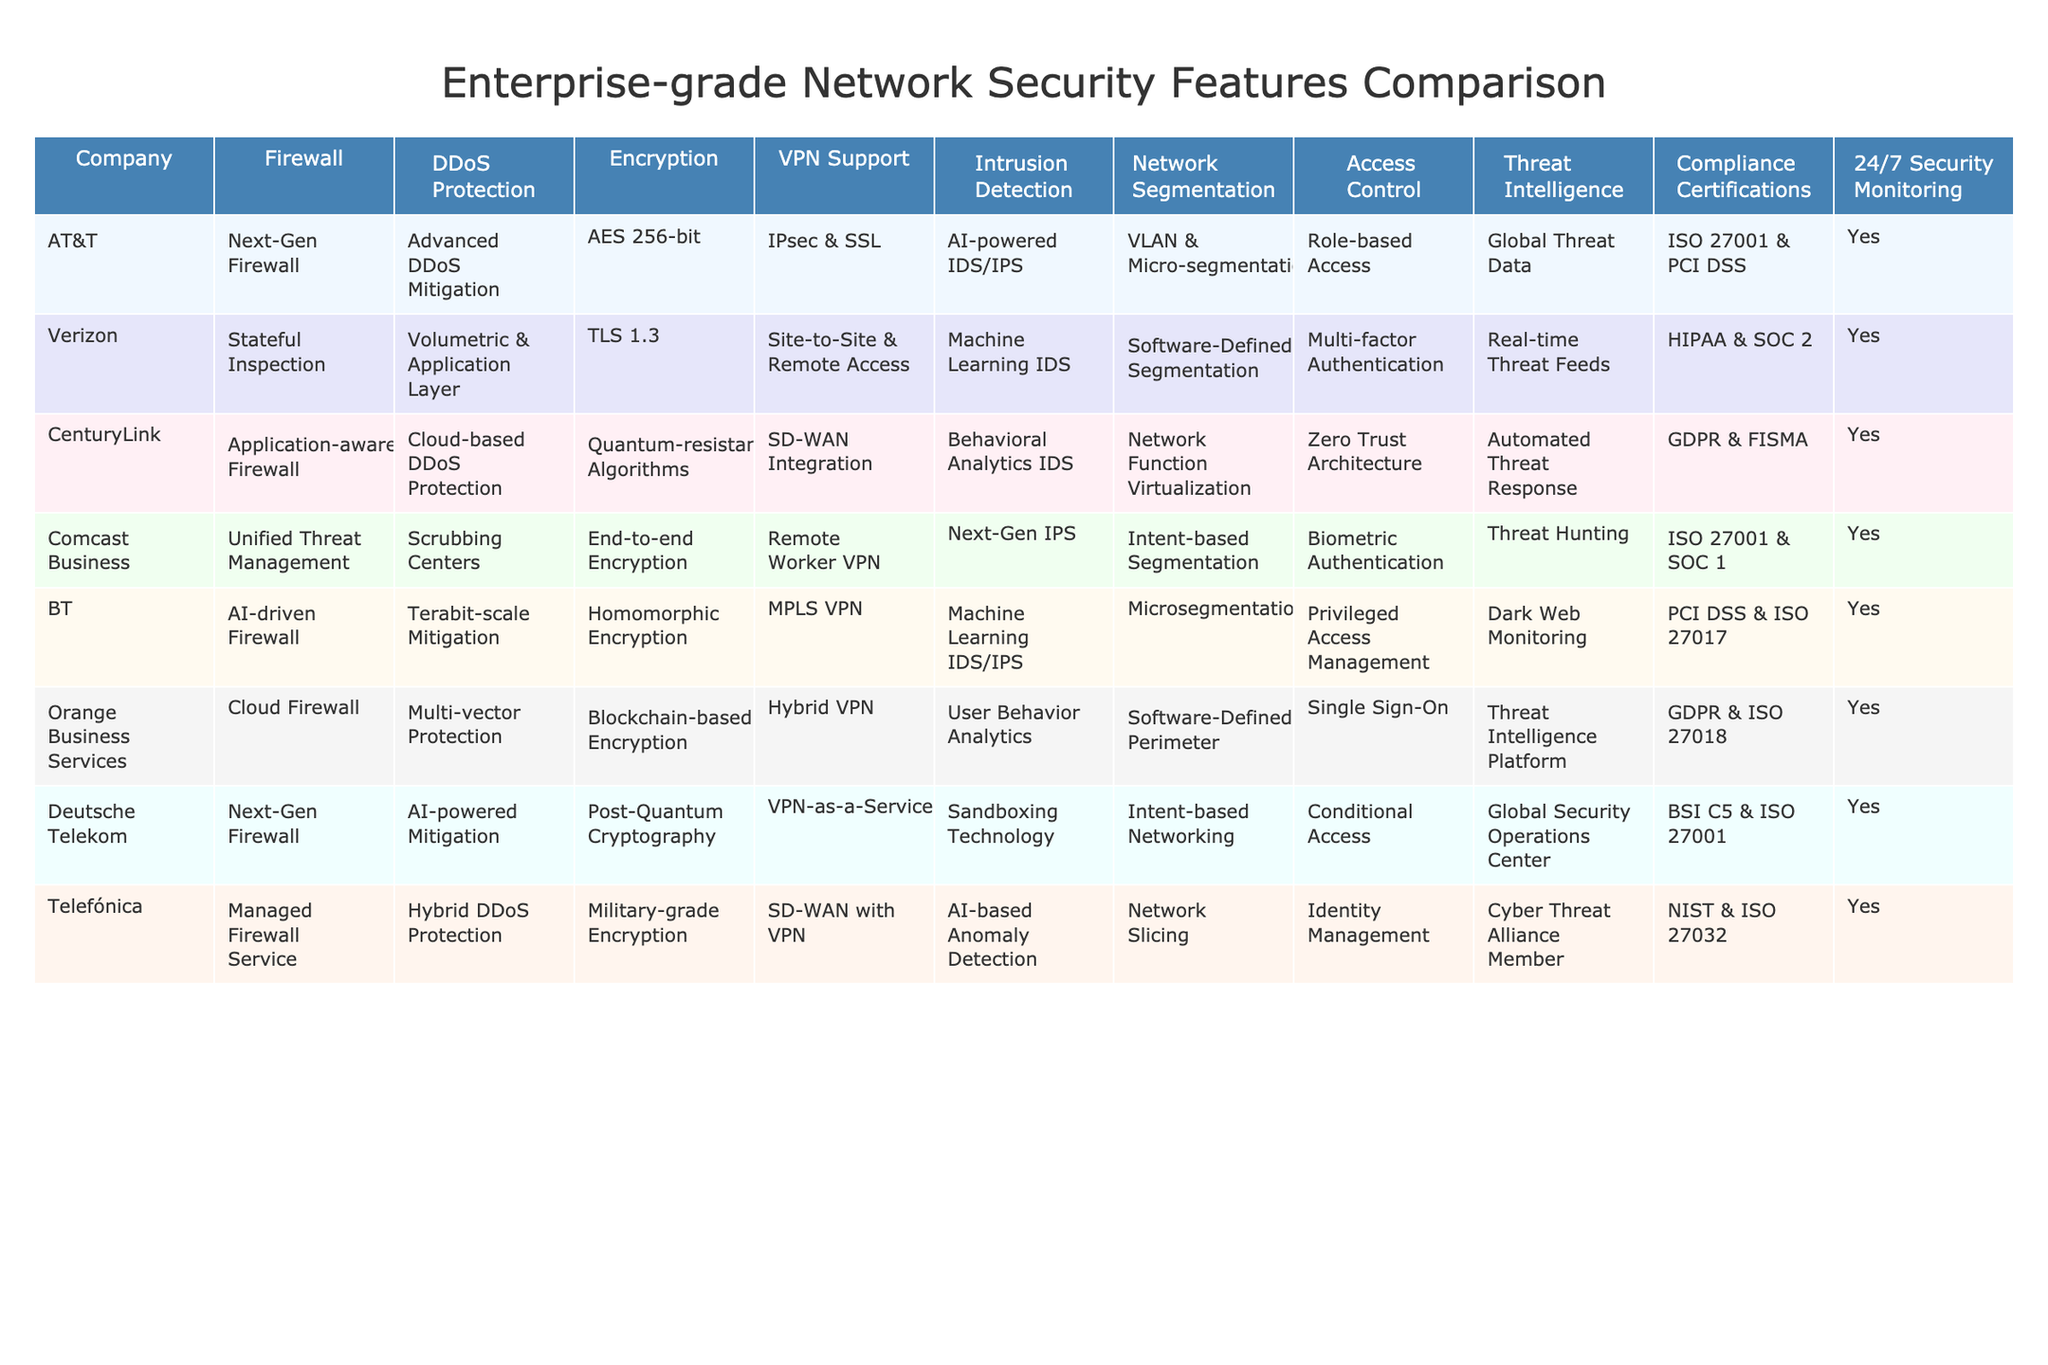What type of firewall does CenturyLink use? According to the table, CenturyLink uses an application-aware firewall. This specific detail can be found in the 'Firewall' column corresponding to the CenturyLink row.
Answer: Application-aware Firewall Which companies offer advanced DDoS protection? The companies that offer advanced DDoS protection are AT&T with advanced DDoS mitigation, Verizon with volumetric and application layer protection, and CenturyLink with cloud-based DDoS protection. This is established by looking under the 'DDoS Protection' column for each company's name.
Answer: AT&T, Verizon, CenturyLink Does Comcast Business provide 24/7 security monitoring? The table indicates that Comcast Business does provide 24/7 security monitoring, as indicated by the 'Yes' in the '24/7 Security Monitoring' column for that company.
Answer: Yes How many companies support VPN? By reviewing the table, it can be observed that all companies listed support VPN services, as each corresponding row has a VPN support option mentioned under the 'VPN Support' column. Since there are 8 companies listed, the count is 8.
Answer: 8 Which company has the highest level of encryption? The question is a bit complex as it requires assessing the encryption types listed. CenturyLink mentions quantum-resistant algorithms which are considered highly secure, while other companies mention AES 256-bit or military-grade encryption which are also high but not at the same advanced level. Thus, CenturyLink leads in encryption sophistication.
Answer: CenturyLink How does the compliance certification of BT differ from that of Verizon? BT has PCI DSS and ISO 27017, while Verizon has HIPAA and SOC 2. This means BT's certifications focus on payment security and cloud security, while Verizon's are in healthcare and organizational security compliance. The answer arises from examining the specific certifications listed in the 'Compliance Certifications' column for both companies.
Answer: Different focus areas Which company offers network segmentation through a zero-trust architecture? The table shows that CenturyLink implements network segmentation through a zero trust architecture, which can be found under the 'Network Segmentation' column in its respective row.
Answer: CenturyLink Compare the encryption methods of AT&T and Deutsche Telekom. AT&T employs AES 256-bit encryption, while Deutsche Telekom uses post-quantum cryptography, which is future-proof against quantum attacks. This comparison requires observing the 'Encryption' column for both companies and understanding the security levels of each encryption method.
Answer: Different encryption approaches How many companies use AI in their intrusion detection systems? From the table, it's evident that AT&T, Verizon, BT, and Telefónica utilize AI in their intrusion detection systems. By counting the occurrences of 'AI' in the 'Intrusion Detection' column, we find that there are 4 companies.
Answer: 4 